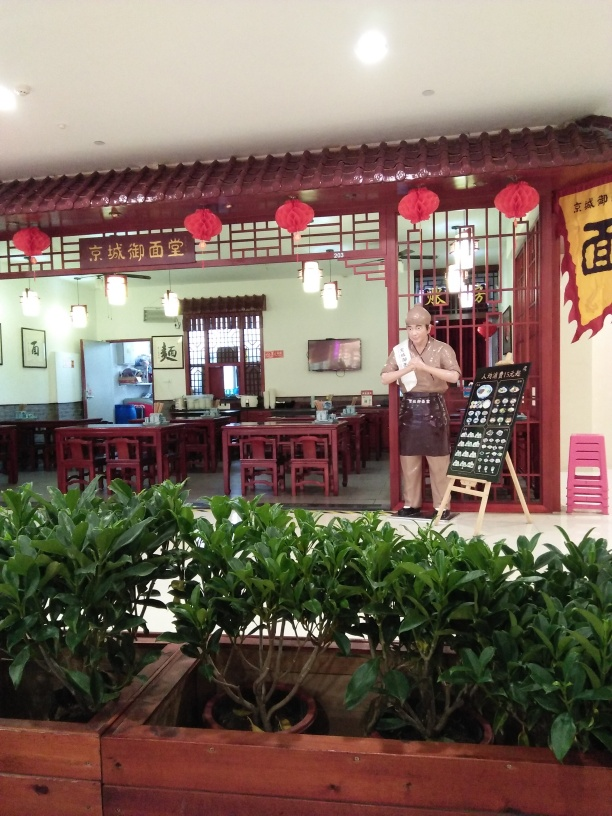Can you describe the style of the restaurant shown in this image? The restaurant features a traditional Chinese aesthetic, with wooden lattice work decorating the windows and walls, red lanterns that symbolize good luck and fortune, and calligraphy artwork adorning the walls. The furniture is also traditional, with square wooden tables and matching chairs. These elements create an ambiance that is both welcoming and culturally rich.  What type of establishment does this appear to be and how can you tell? Based on the image, this appears to be a traditional Chinese tea house or dining establishment. Indicators include the menu board outside, which suggests food or drink offerings, the apron worn by the individual, signifying a staff member or owner, and the presence of multiple dining tables arranged throughout the room. The atmosphere implies a place designed for patrons to sit, dine, or enjoy tea. 